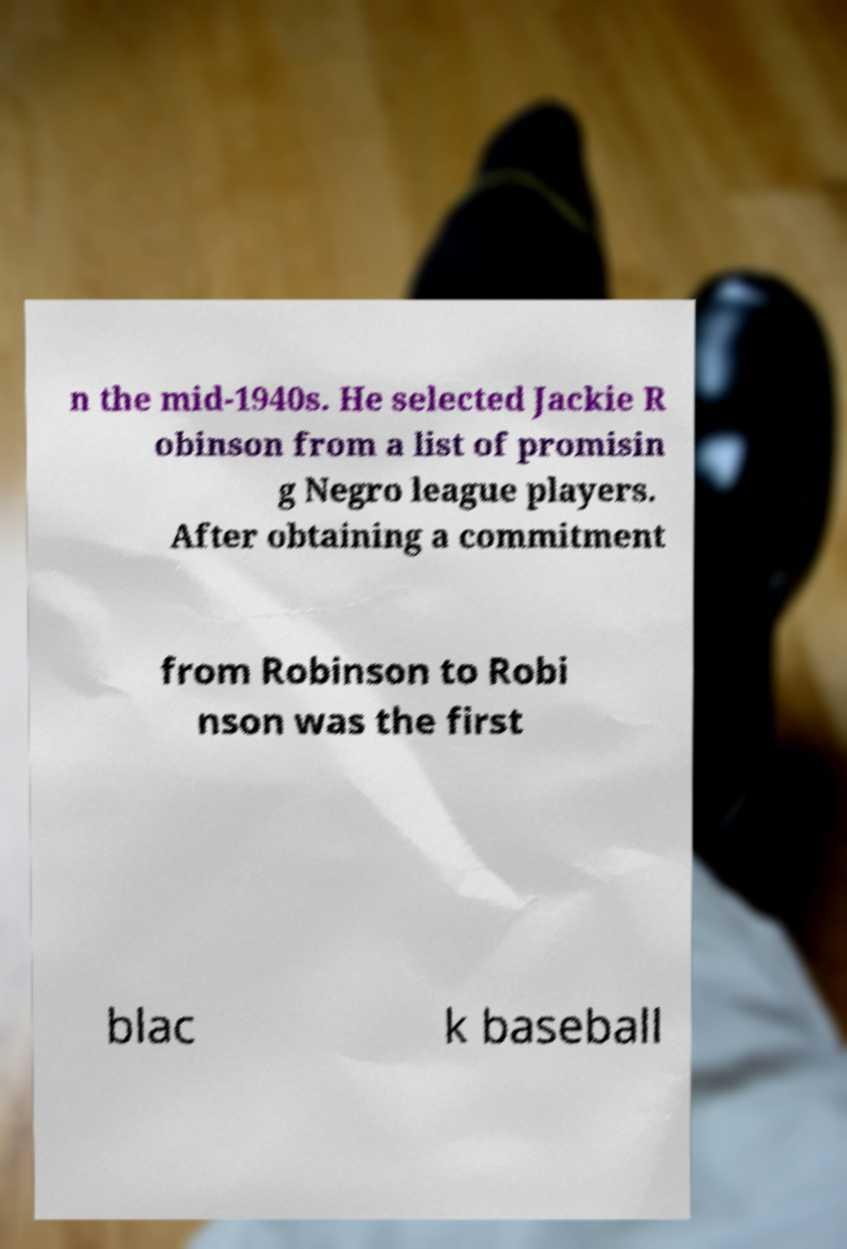For documentation purposes, I need the text within this image transcribed. Could you provide that? n the mid-1940s. He selected Jackie R obinson from a list of promisin g Negro league players. After obtaining a commitment from Robinson to Robi nson was the first blac k baseball 